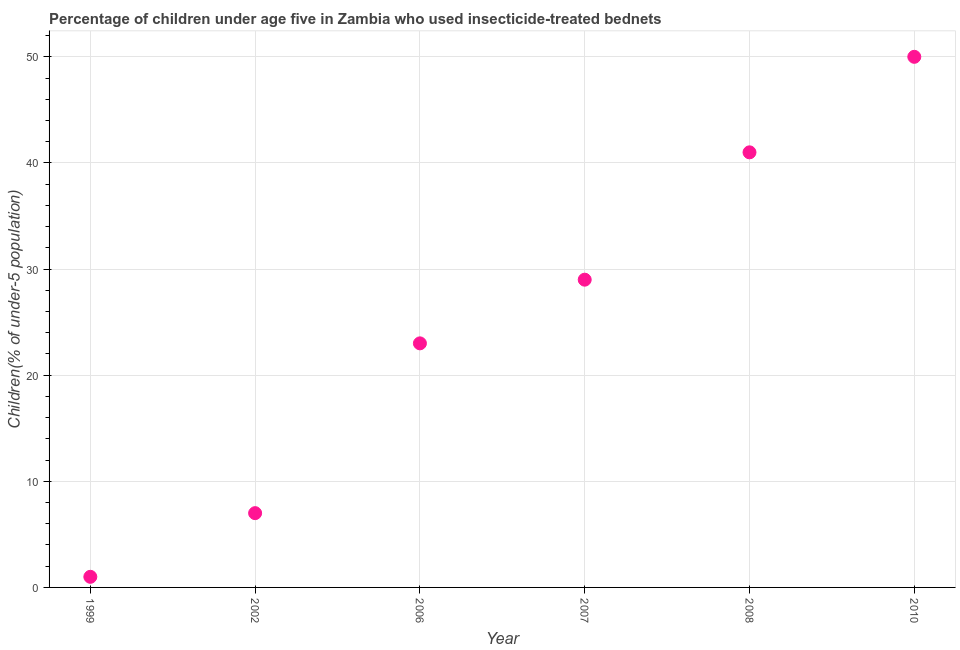What is the percentage of children who use of insecticide-treated bed nets in 2006?
Offer a terse response. 23. Across all years, what is the maximum percentage of children who use of insecticide-treated bed nets?
Ensure brevity in your answer.  50. Across all years, what is the minimum percentage of children who use of insecticide-treated bed nets?
Make the answer very short. 1. What is the sum of the percentage of children who use of insecticide-treated bed nets?
Offer a very short reply. 151. What is the difference between the percentage of children who use of insecticide-treated bed nets in 2008 and 2010?
Ensure brevity in your answer.  -9. What is the average percentage of children who use of insecticide-treated bed nets per year?
Offer a terse response. 25.17. What is the median percentage of children who use of insecticide-treated bed nets?
Your answer should be compact. 26. In how many years, is the percentage of children who use of insecticide-treated bed nets greater than 50 %?
Your response must be concise. 0. Do a majority of the years between 2007 and 2008 (inclusive) have percentage of children who use of insecticide-treated bed nets greater than 16 %?
Ensure brevity in your answer.  Yes. What is the ratio of the percentage of children who use of insecticide-treated bed nets in 2002 to that in 2010?
Provide a succinct answer. 0.14. Is the percentage of children who use of insecticide-treated bed nets in 2007 less than that in 2010?
Provide a short and direct response. Yes. What is the difference between the highest and the lowest percentage of children who use of insecticide-treated bed nets?
Offer a terse response. 49. In how many years, is the percentage of children who use of insecticide-treated bed nets greater than the average percentage of children who use of insecticide-treated bed nets taken over all years?
Give a very brief answer. 3. How many dotlines are there?
Make the answer very short. 1. What is the difference between two consecutive major ticks on the Y-axis?
Offer a terse response. 10. What is the title of the graph?
Offer a very short reply. Percentage of children under age five in Zambia who used insecticide-treated bednets. What is the label or title of the Y-axis?
Offer a terse response. Children(% of under-5 population). What is the Children(% of under-5 population) in 2006?
Your answer should be very brief. 23. What is the Children(% of under-5 population) in 2007?
Keep it short and to the point. 29. What is the Children(% of under-5 population) in 2010?
Your response must be concise. 50. What is the difference between the Children(% of under-5 population) in 1999 and 2007?
Give a very brief answer. -28. What is the difference between the Children(% of under-5 population) in 1999 and 2008?
Ensure brevity in your answer.  -40. What is the difference between the Children(% of under-5 population) in 1999 and 2010?
Offer a terse response. -49. What is the difference between the Children(% of under-5 population) in 2002 and 2007?
Your answer should be very brief. -22. What is the difference between the Children(% of under-5 population) in 2002 and 2008?
Provide a succinct answer. -34. What is the difference between the Children(% of under-5 population) in 2002 and 2010?
Your answer should be compact. -43. What is the difference between the Children(% of under-5 population) in 2006 and 2008?
Make the answer very short. -18. What is the difference between the Children(% of under-5 population) in 2007 and 2008?
Ensure brevity in your answer.  -12. What is the difference between the Children(% of under-5 population) in 2007 and 2010?
Offer a terse response. -21. What is the difference between the Children(% of under-5 population) in 2008 and 2010?
Offer a very short reply. -9. What is the ratio of the Children(% of under-5 population) in 1999 to that in 2002?
Provide a short and direct response. 0.14. What is the ratio of the Children(% of under-5 population) in 1999 to that in 2006?
Make the answer very short. 0.04. What is the ratio of the Children(% of under-5 population) in 1999 to that in 2007?
Provide a succinct answer. 0.03. What is the ratio of the Children(% of under-5 population) in 1999 to that in 2008?
Your answer should be very brief. 0.02. What is the ratio of the Children(% of under-5 population) in 2002 to that in 2006?
Make the answer very short. 0.3. What is the ratio of the Children(% of under-5 population) in 2002 to that in 2007?
Offer a terse response. 0.24. What is the ratio of the Children(% of under-5 population) in 2002 to that in 2008?
Keep it short and to the point. 0.17. What is the ratio of the Children(% of under-5 population) in 2002 to that in 2010?
Provide a short and direct response. 0.14. What is the ratio of the Children(% of under-5 population) in 2006 to that in 2007?
Make the answer very short. 0.79. What is the ratio of the Children(% of under-5 population) in 2006 to that in 2008?
Offer a terse response. 0.56. What is the ratio of the Children(% of under-5 population) in 2006 to that in 2010?
Provide a short and direct response. 0.46. What is the ratio of the Children(% of under-5 population) in 2007 to that in 2008?
Ensure brevity in your answer.  0.71. What is the ratio of the Children(% of under-5 population) in 2007 to that in 2010?
Your response must be concise. 0.58. What is the ratio of the Children(% of under-5 population) in 2008 to that in 2010?
Offer a very short reply. 0.82. 